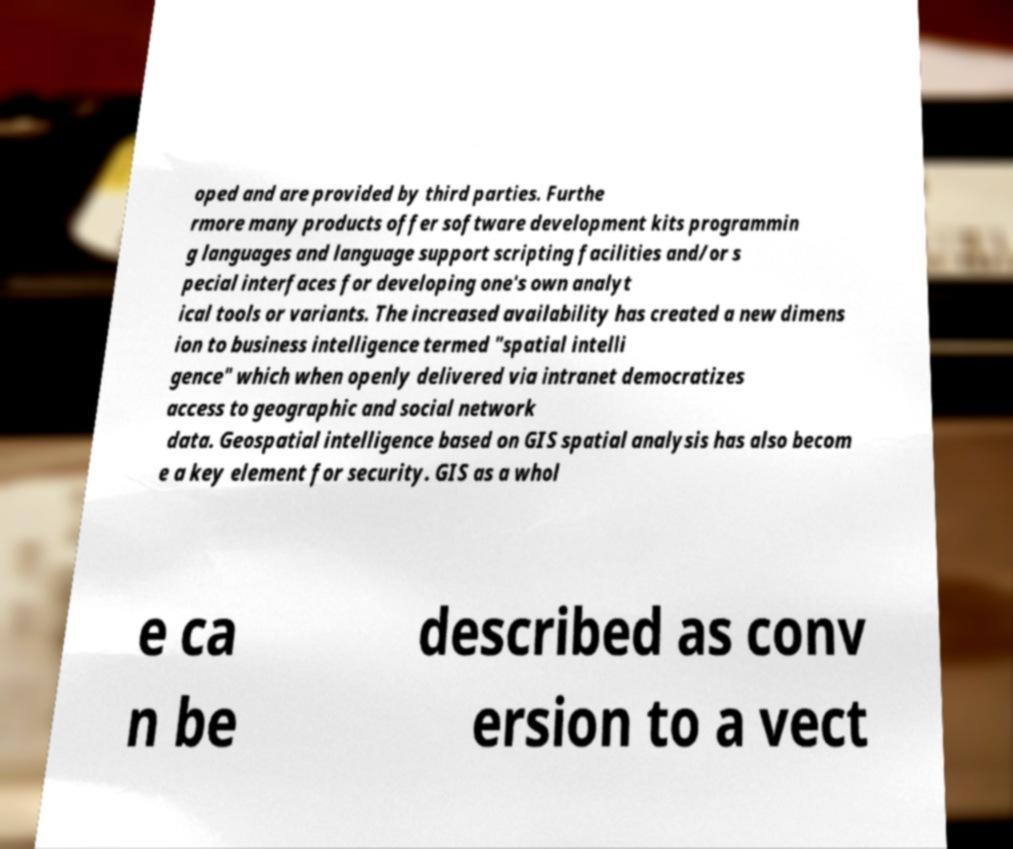Can you read and provide the text displayed in the image?This photo seems to have some interesting text. Can you extract and type it out for me? oped and are provided by third parties. Furthe rmore many products offer software development kits programmin g languages and language support scripting facilities and/or s pecial interfaces for developing one's own analyt ical tools or variants. The increased availability has created a new dimens ion to business intelligence termed "spatial intelli gence" which when openly delivered via intranet democratizes access to geographic and social network data. Geospatial intelligence based on GIS spatial analysis has also becom e a key element for security. GIS as a whol e ca n be described as conv ersion to a vect 